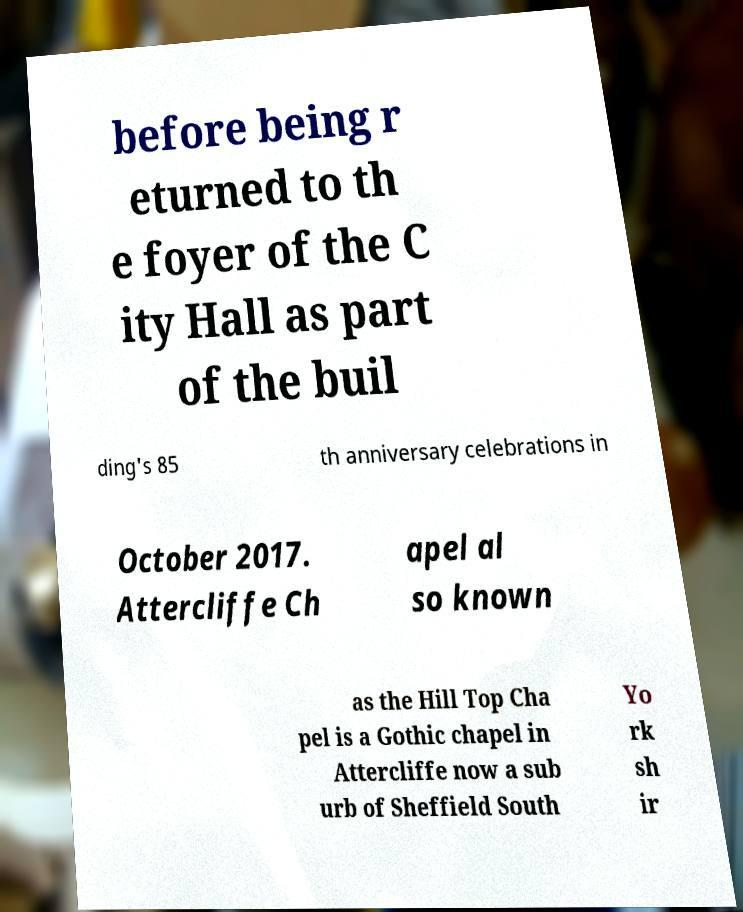Please identify and transcribe the text found in this image. before being r eturned to th e foyer of the C ity Hall as part of the buil ding's 85 th anniversary celebrations in October 2017. Attercliffe Ch apel al so known as the Hill Top Cha pel is a Gothic chapel in Attercliffe now a sub urb of Sheffield South Yo rk sh ir 